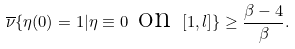<formula> <loc_0><loc_0><loc_500><loc_500>\overline { \nu } \{ \eta ( 0 ) = 1 | \eta \equiv 0 \text { on } [ 1 , l ] \} \geq \frac { \beta - 4 } { \beta } .</formula> 